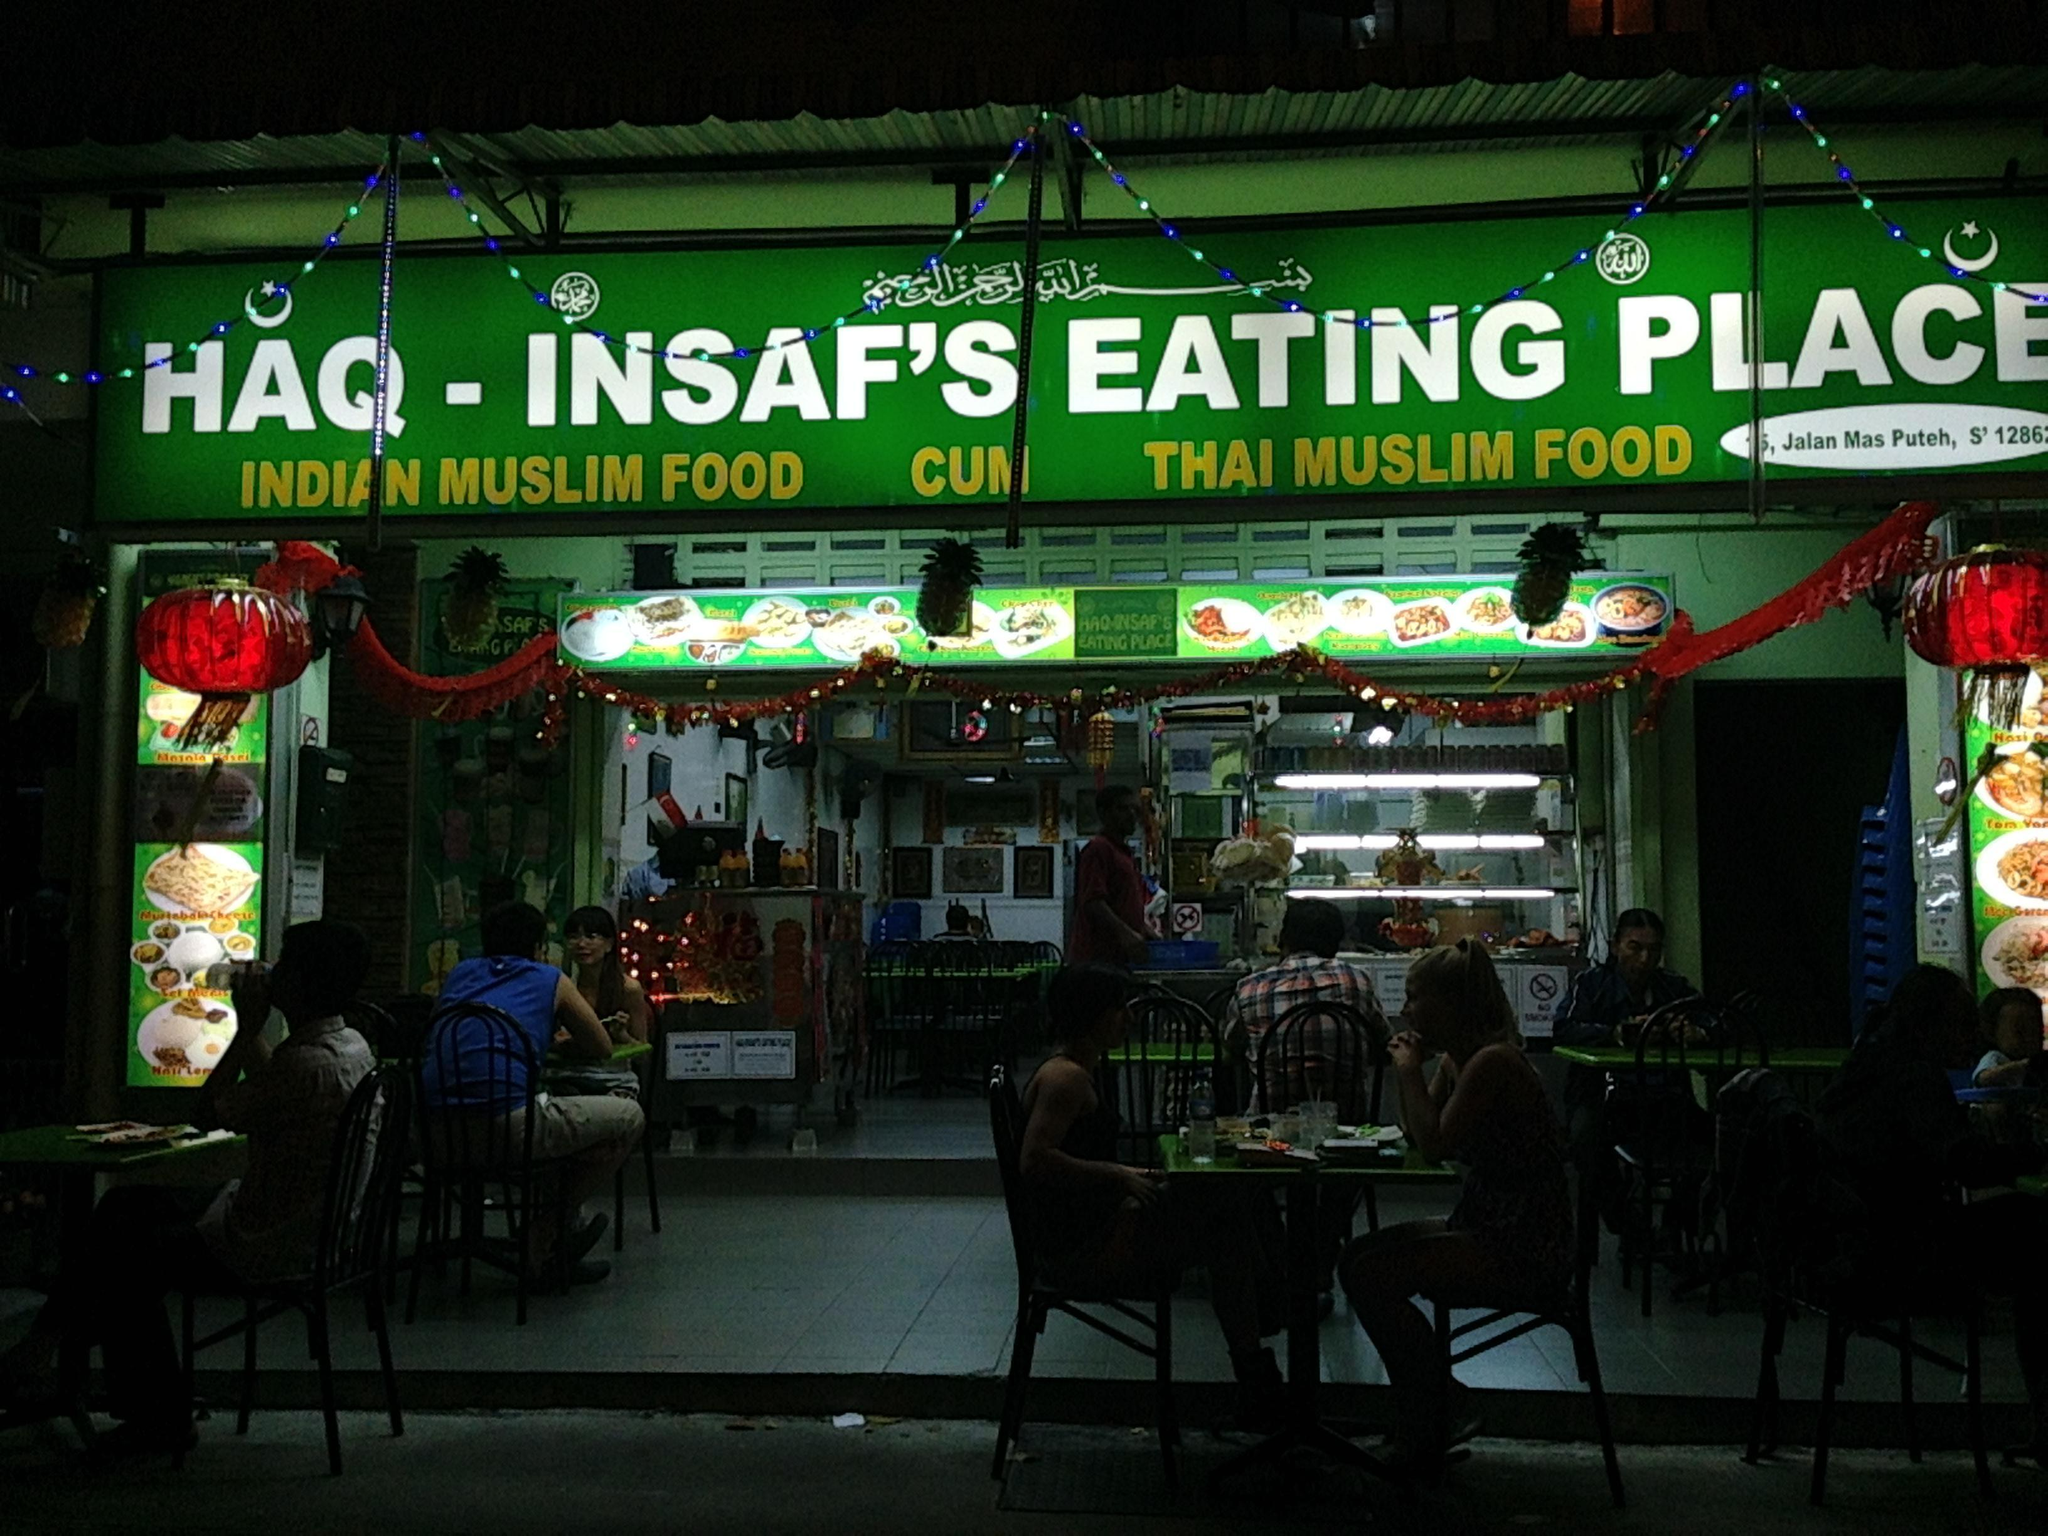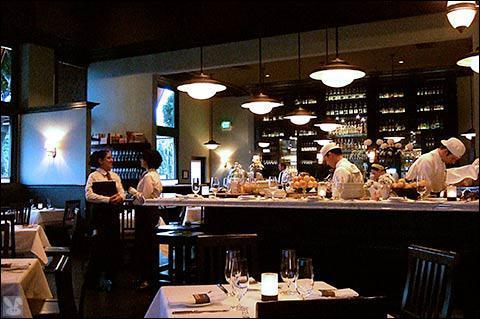The first image is the image on the left, the second image is the image on the right. Analyze the images presented: Is the assertion "One image shows a flat-topped building with a sign lettered in two colors above a row of six rectangular windows." valid? Answer yes or no. No. 